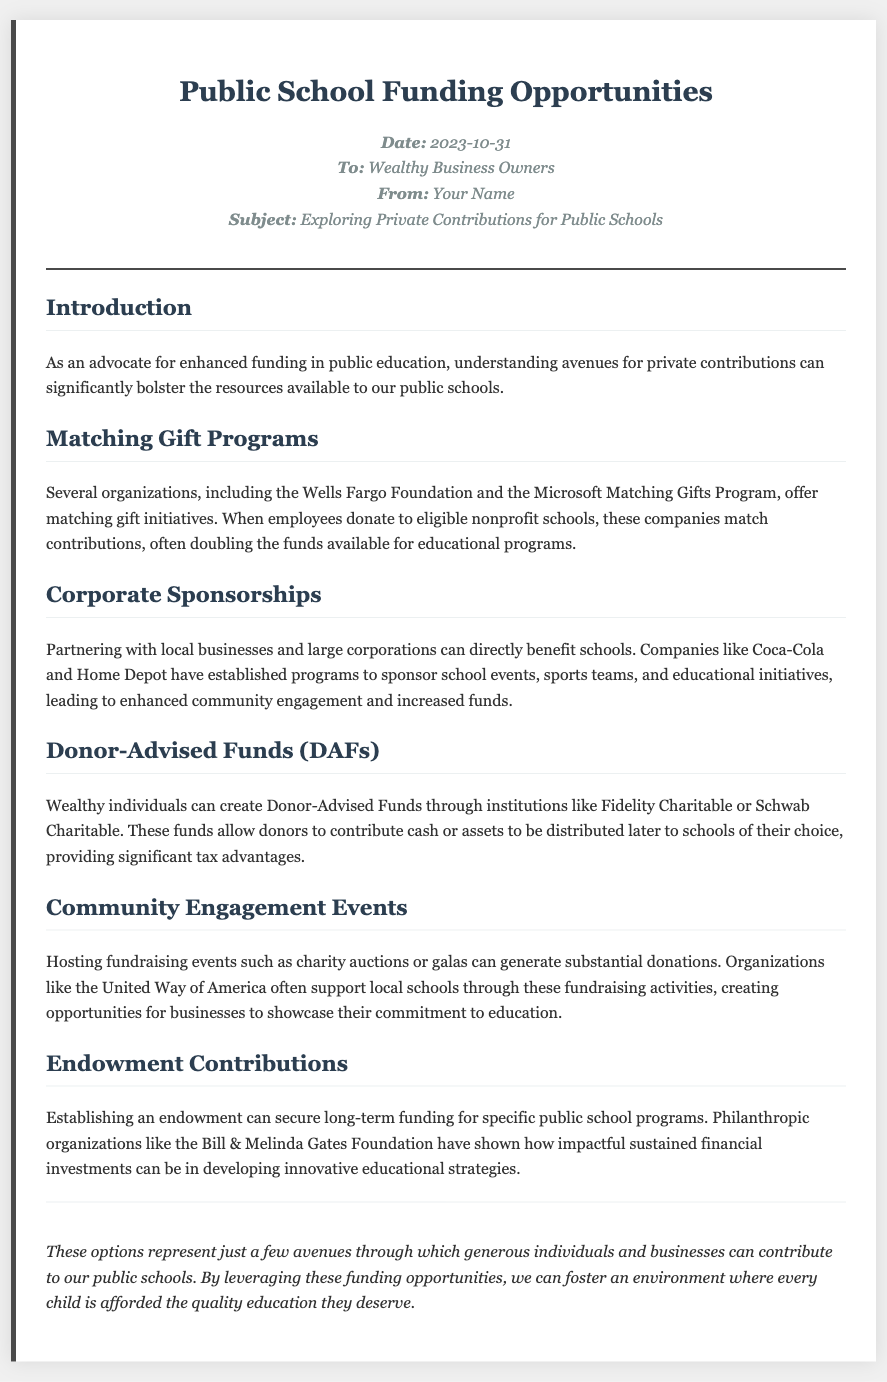what is the date of the memo? The date of the memo is stated in the header section.
Answer: 2023-10-31 who is the memo addressed to? The memo is directed at a specific audience mentioned in the introductory section.
Answer: Wealthy Business Owners which organizations are mentioned in the matching gift programs section? The matching gift programs section lists specific organizations that participate in matching gifts.
Answer: Wells Fargo Foundation and Microsoft what are the two types of contributions discussed in the memo? The memo details avenues for contributions which involve community engagement events and long-term funding.
Answer: Matching Gift Programs and Corporate Sponsorships which foundations are mentioned as providers for Donor-Advised Funds? The mention of specific institutions in the section on Donor-Advised Funds indicates the providers available for these funds.
Answer: Fidelity Charitable or Schwab Charitable how can corporations contribute according to the memo? The document explains how local businesses and corporations can support the school system financially.
Answer: Corporate Sponsorships what is the primary focus of the closing section? The closing section summarizes the overall aim or purpose of the memo regarding contributions to education.
Answer: Contributions to public schools what type of fundraising activities are suggested in the community engagement events section? The document highlights specific types of fundraising activities that may benefit public schools.
Answer: Charity auctions or galas 